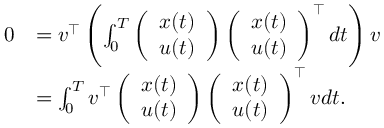<formula> <loc_0><loc_0><loc_500><loc_500>\begin{array} { r l } { 0 } & { = v ^ { \top } \left ( \int _ { 0 } ^ { T } \left ( \begin{array} { l } { x ( t ) } \\ { u ( t ) } \end{array} \right ) \left ( \begin{array} { l } { x ( t ) } \\ { u ( t ) } \end{array} \right ) ^ { \top } d t \right ) v } \\ & { = \int _ { 0 } ^ { T } v ^ { \top } \left ( \begin{array} { l } { x ( t ) } \\ { u ( t ) } \end{array} \right ) \left ( \begin{array} { l } { x ( t ) } \\ { u ( t ) } \end{array} \right ) ^ { \top } v d t . } \end{array}</formula> 